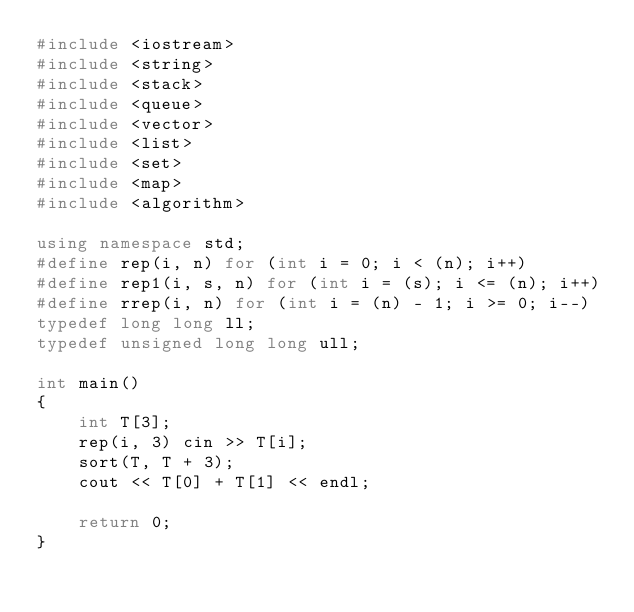Convert code to text. <code><loc_0><loc_0><loc_500><loc_500><_C++_>#include <iostream>
#include <string>
#include <stack>
#include <queue>
#include <vector>
#include <list>
#include <set>
#include <map>
#include <algorithm>

using namespace std;
#define rep(i, n) for (int i = 0; i < (n); i++)
#define rep1(i, s, n) for (int i = (s); i <= (n); i++)
#define rrep(i, n) for (int i = (n) - 1; i >= 0; i--)
typedef long long ll;
typedef unsigned long long ull;

int main()
{
	int T[3];
	rep(i, 3) cin >> T[i];
	sort(T, T + 3);
	cout << T[0] + T[1] << endl;

	return 0;
}
</code> 